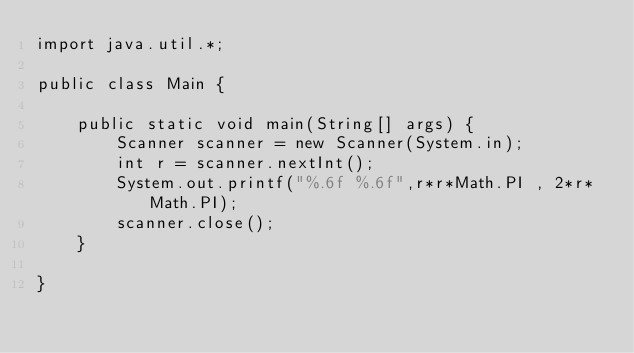Convert code to text. <code><loc_0><loc_0><loc_500><loc_500><_Java_>import java.util.*;

public class Main {

	public static void main(String[] args) {
		Scanner scanner = new Scanner(System.in);
		int r = scanner.nextInt();
		System.out.printf("%.6f %.6f",r*r*Math.PI , 2*r*Math.PI);
		scanner.close();
	}

}</code> 